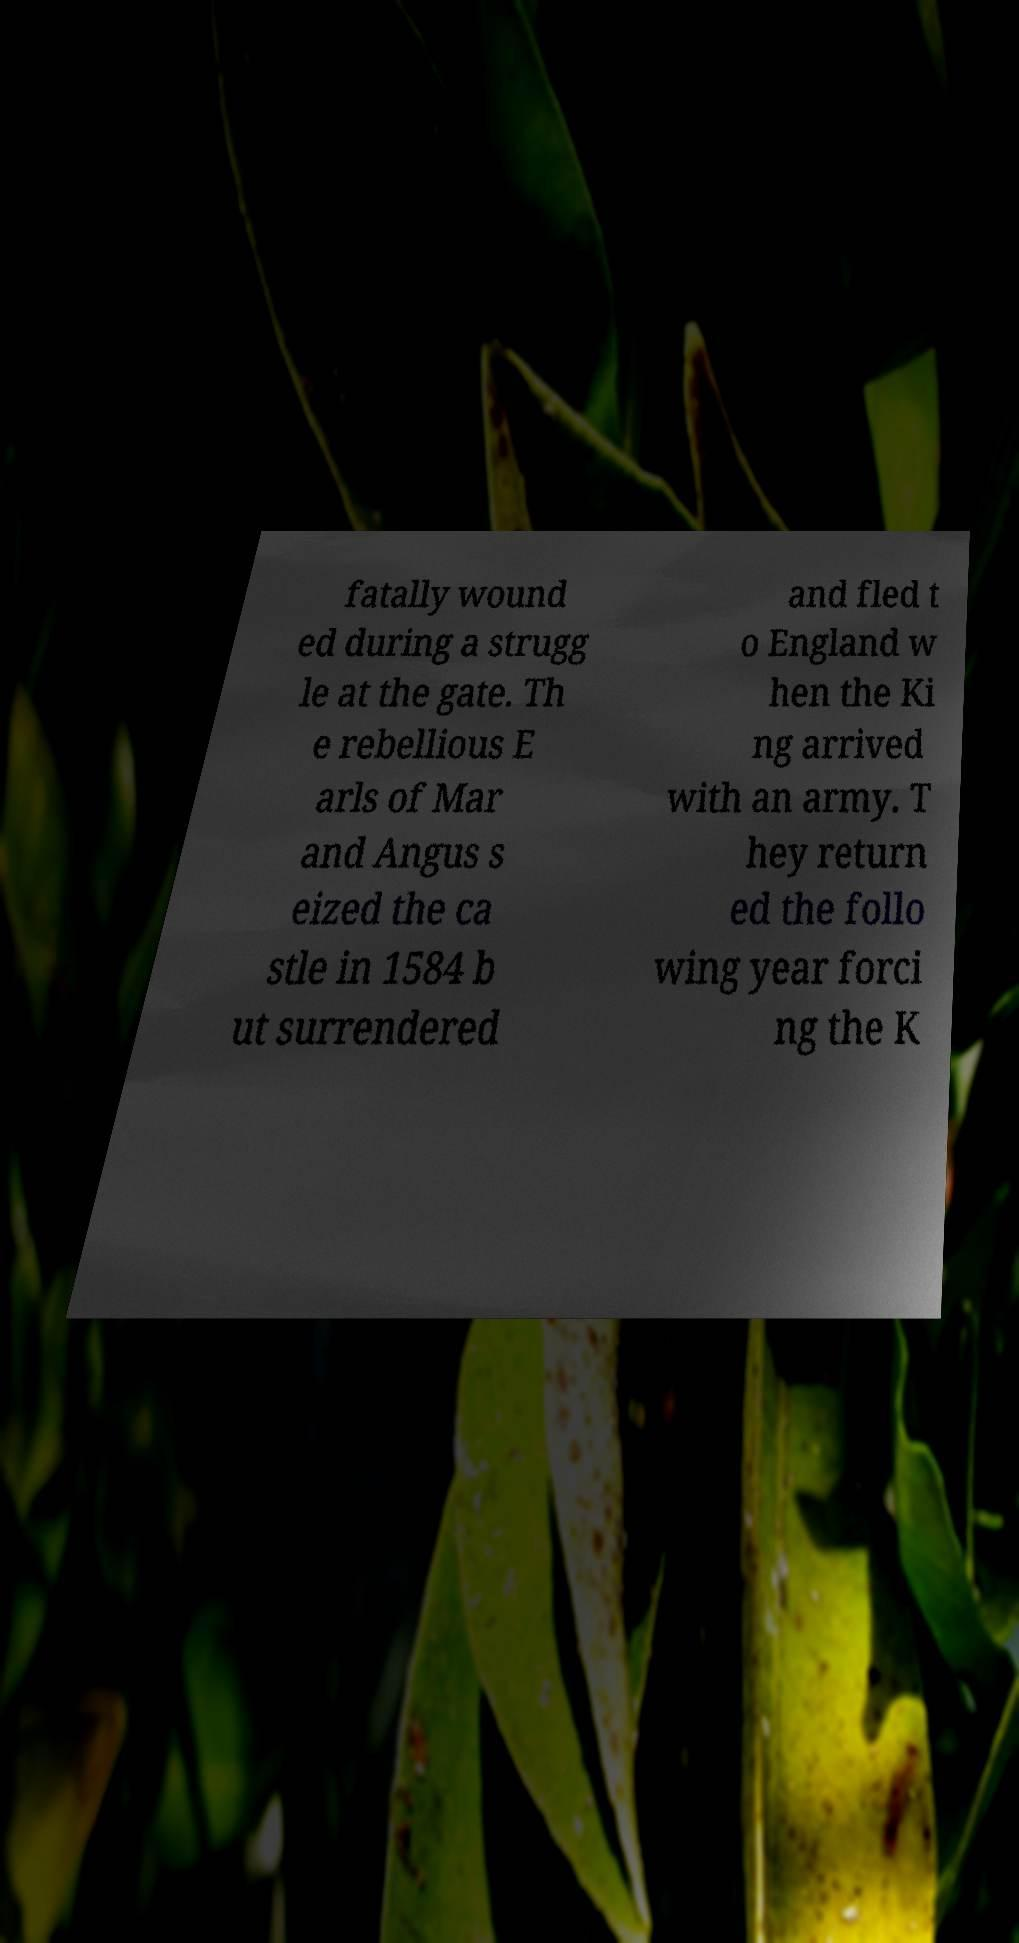For documentation purposes, I need the text within this image transcribed. Could you provide that? fatally wound ed during a strugg le at the gate. Th e rebellious E arls of Mar and Angus s eized the ca stle in 1584 b ut surrendered and fled t o England w hen the Ki ng arrived with an army. T hey return ed the follo wing year forci ng the K 